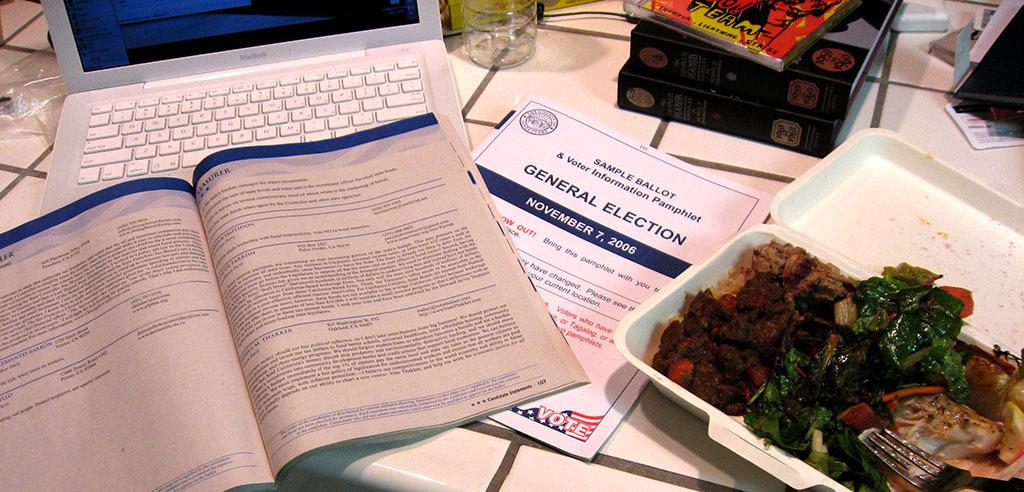What is the date of the general election?
Your answer should be compact. November 7, 2006. Is the book next to the food for general election?
Provide a succinct answer. Yes. 